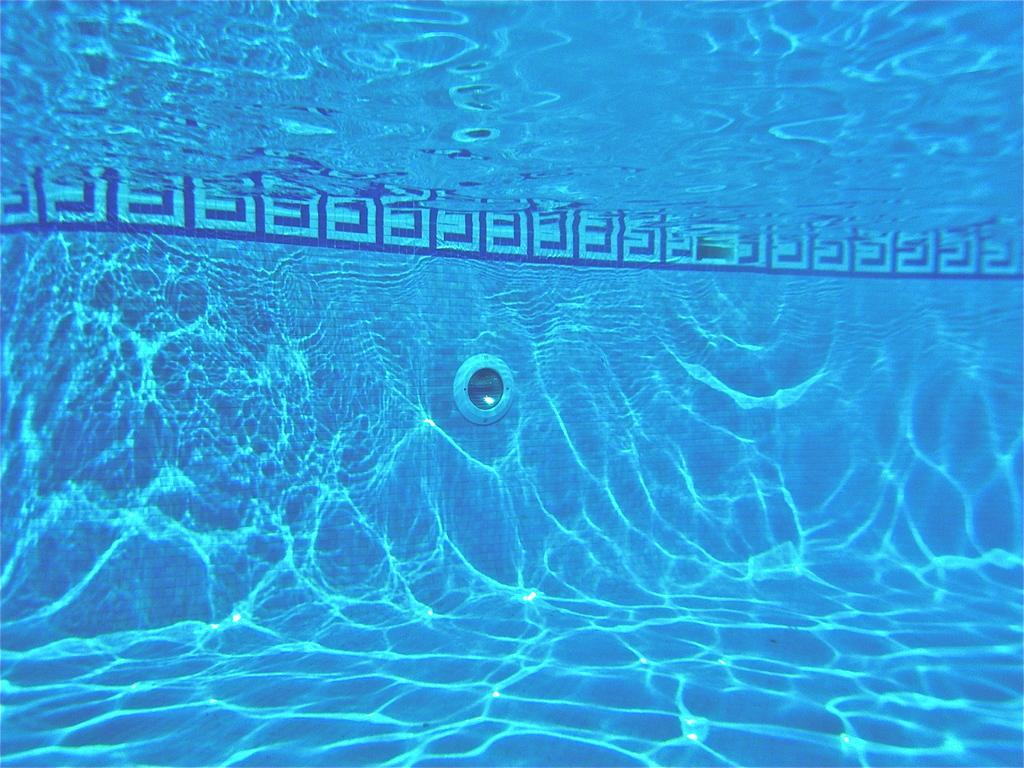Can you describe this image briefly? It is inside the water of a swimming pool. 